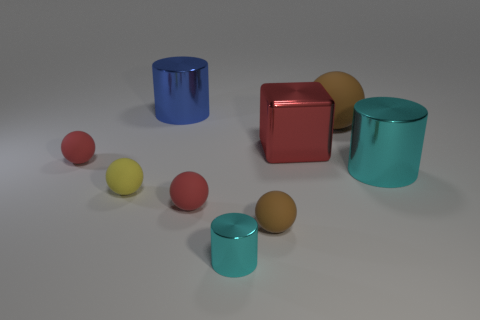Are there an equal number of blue metal cylinders that are right of the big red metal cube and red balls to the left of the blue cylinder?
Your answer should be very brief. No. There is a large cylinder on the right side of the cylinder that is behind the big red block that is behind the tiny cyan cylinder; what is its color?
Your answer should be very brief. Cyan. There is a big object right of the large brown rubber ball; what is its shape?
Your response must be concise. Cylinder. There is a large cyan thing that is the same material as the red block; what is its shape?
Provide a succinct answer. Cylinder. Is there any other thing that has the same shape as the big red metal thing?
Provide a short and direct response. No. What number of red metal things are to the left of the red shiny cube?
Make the answer very short. 0. Is the number of red rubber things that are in front of the large cyan shiny cylinder the same as the number of tiny gray metallic blocks?
Provide a succinct answer. No. Does the tiny brown thing have the same material as the blue thing?
Provide a succinct answer. No. There is a cylinder that is both to the left of the tiny brown thing and on the right side of the big blue metallic cylinder; what is its size?
Ensure brevity in your answer.  Small. What number of other shiny objects have the same size as the blue thing?
Offer a very short reply. 2. 